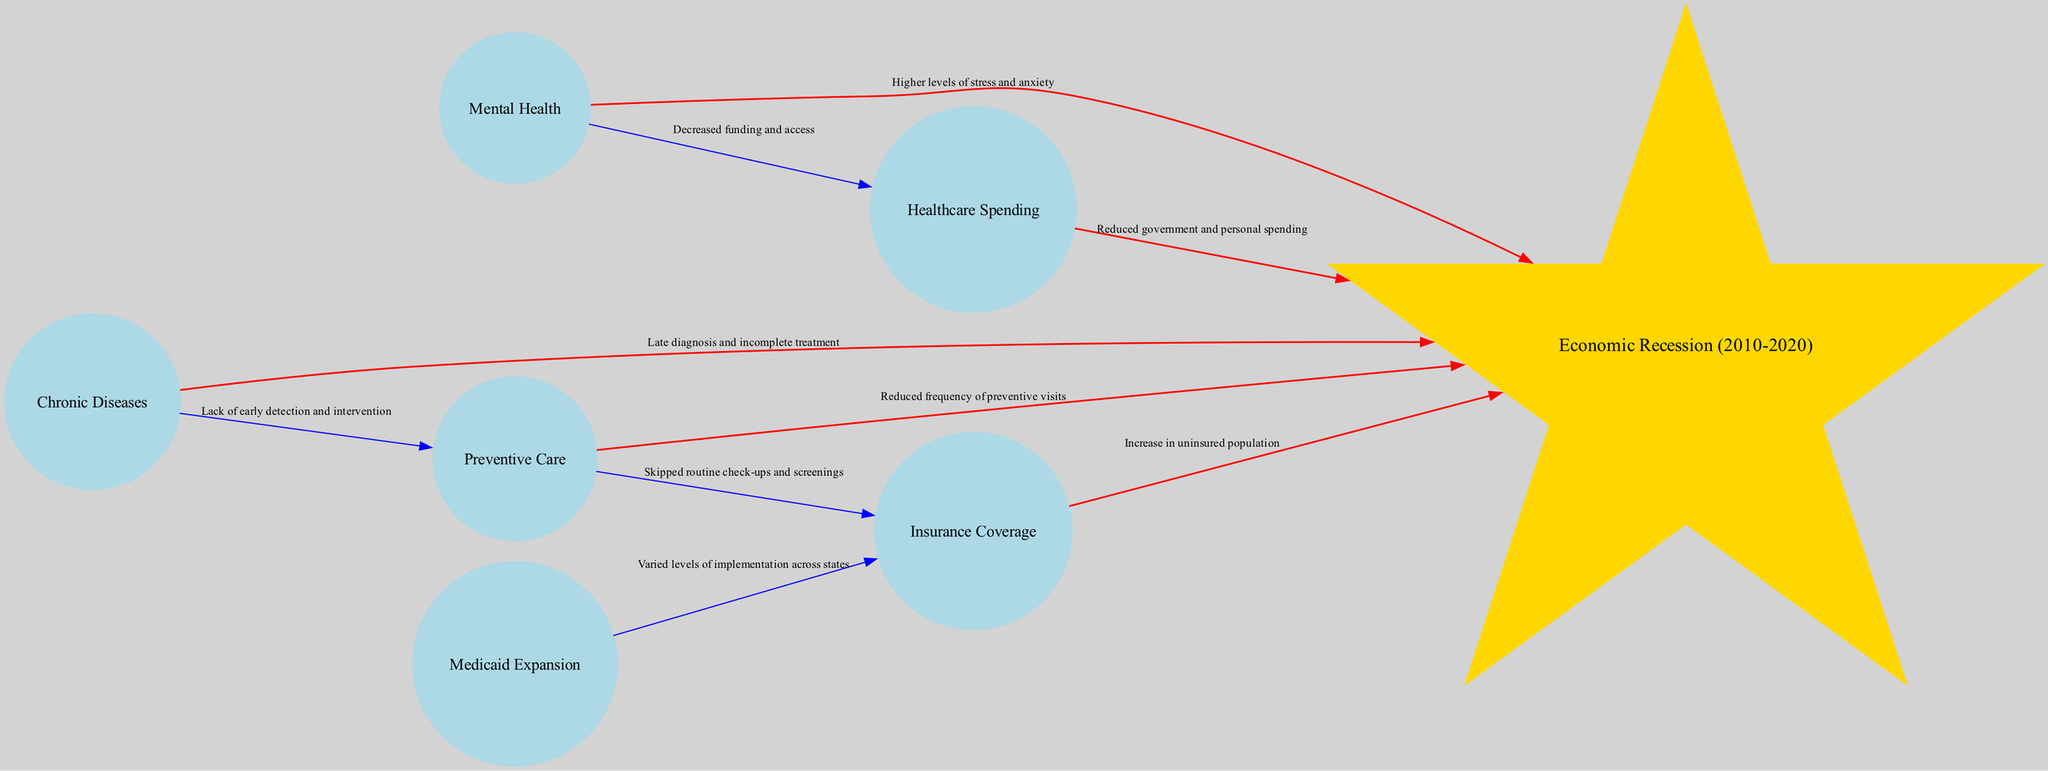What is the central node of the diagram? The central node is labeled "Economic Recession (2010-2020)," which is clearly indicated in the diagram.
Answer: Economic Recession (2010-2020) How many satellite nodes are in the diagram? Counting the satellite nodes listed under the central node, there are six satellite nodes present in the diagram.
Answer: 6 What relationship connects "Healthcare Spending" to the central node? The relationship connecting "Healthcare Spending" to the central node is labeled "Reduced government and personal spending," as shown in the diagram.
Answer: Reduced government and personal spending What is the impact of the economic recession on mental health? The diagram indicates that the relationship is "Higher levels of stress and anxiety," reflecting how the recession has impacted mental health.
Answer: Higher levels of stress and anxiety What effect does the economic recession have on chronic diseases? The economic recession leads to "Late diagnosis and incomplete treatment" concerning chronic diseases, as detailed by the connections in the diagram.
Answer: Late diagnosis and incomplete treatment Which satellite node has a direct connection to "Insurance Coverage"? The diagram shows that "Medicaid Expansion" has a direct connection to "Insurance Coverage," represented in the relationships depicted.
Answer: Medicaid Expansion How does preventive care relate to the economic recession? The relationship notes "Reduced frequency of preventive visits," indicating that the economic recession has decreased the number of preventive care visits.
Answer: Reduced frequency of preventive visits What is implied about routine check-ups in relation to insurance coverage? The diagram states that there is a relationship labeled "Skipped routine check-ups and screenings," linking preventive care to insurance coverage.
Answer: Skipped routine check-ups and screenings What does the diagram suggest about Medicaid expansion? The diagram indicates that Medicaid expansion has "Varied levels of implementation across states," which is crucial for understanding its impact on insurance coverage during the recession.
Answer: Varied levels of implementation across states 